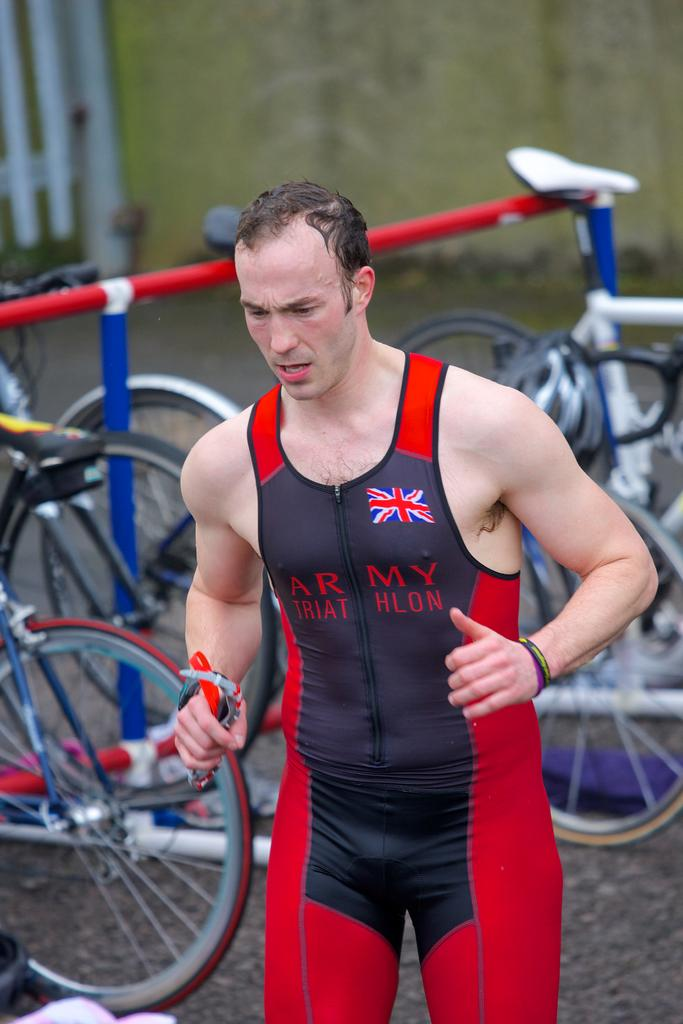<image>
Present a compact description of the photo's key features. A triathlon runner runs by bicycles wearing an Army triathlon outfit. 